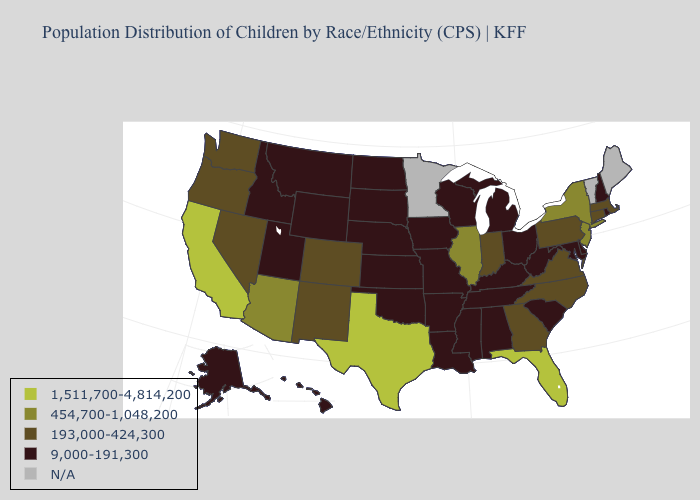Name the states that have a value in the range N/A?
Write a very short answer. Maine, Minnesota, Vermont. Does the first symbol in the legend represent the smallest category?
Give a very brief answer. No. What is the value of Iowa?
Concise answer only. 9,000-191,300. What is the highest value in the West ?
Write a very short answer. 1,511,700-4,814,200. What is the lowest value in states that border Michigan?
Keep it brief. 9,000-191,300. Name the states that have a value in the range 193,000-424,300?
Write a very short answer. Colorado, Connecticut, Georgia, Indiana, Massachusetts, Nevada, New Mexico, North Carolina, Oregon, Pennsylvania, Virginia, Washington. Name the states that have a value in the range 193,000-424,300?
Be succinct. Colorado, Connecticut, Georgia, Indiana, Massachusetts, Nevada, New Mexico, North Carolina, Oregon, Pennsylvania, Virginia, Washington. What is the value of New Hampshire?
Concise answer only. 9,000-191,300. How many symbols are there in the legend?
Give a very brief answer. 5. What is the value of Maryland?
Quick response, please. 9,000-191,300. What is the highest value in the South ?
Answer briefly. 1,511,700-4,814,200. What is the value of Arizona?
Short answer required. 454,700-1,048,200. What is the value of Idaho?
Give a very brief answer. 9,000-191,300. Does Illinois have the lowest value in the USA?
Give a very brief answer. No. 